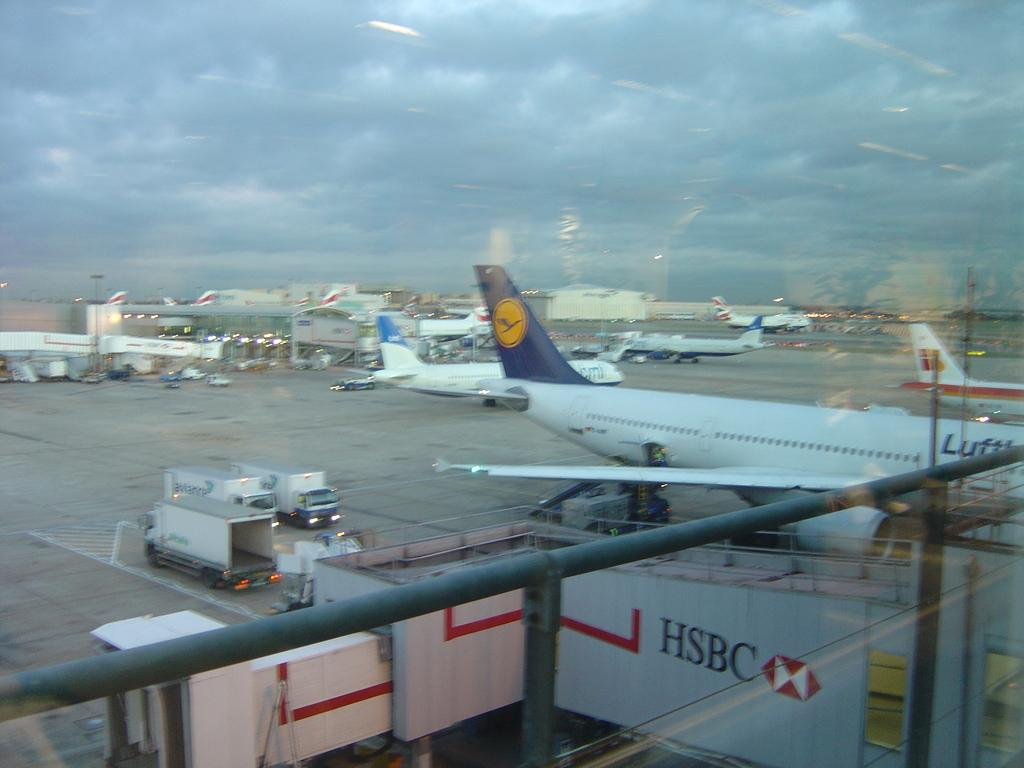What type of objects can be seen in the image that are made of metal? There are metal rods in the image. What other objects can be seen in the image that are not made of metal? There are poles, containers, vehicles, and an airplane in the image. What can be seen in the background of the image? There are buildings, clouds, and lights visible in the background of the image. What type of watch can be seen on the airplane in the image? There is no watch visible on the airplane in the image. What type of marble is present in the image? There is no marble present in the image. 